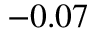<formula> <loc_0><loc_0><loc_500><loc_500>- 0 . 0 7</formula> 